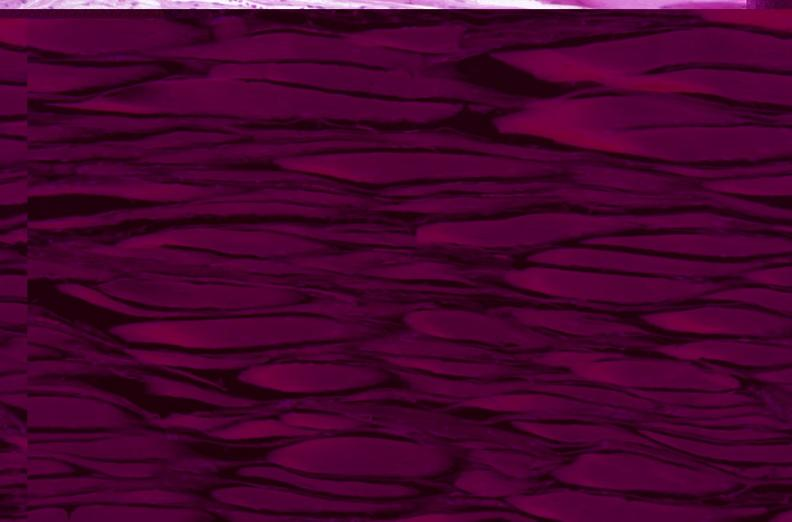why does this image show skeletal muscle, atrophy?
Answer the question using a single word or phrase. Due to immobilization cast 